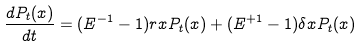<formula> <loc_0><loc_0><loc_500><loc_500>\frac { d P _ { t } ( x ) } { d t } = ( E ^ { - 1 } - 1 ) r x P _ { t } ( x ) + ( E ^ { + 1 } - 1 ) \delta x P _ { t } ( x )</formula> 